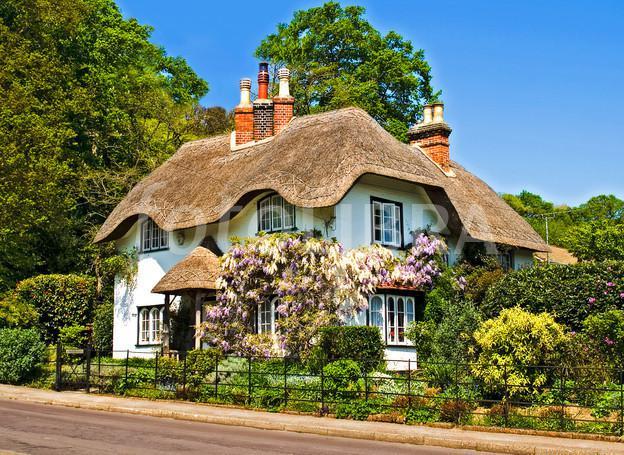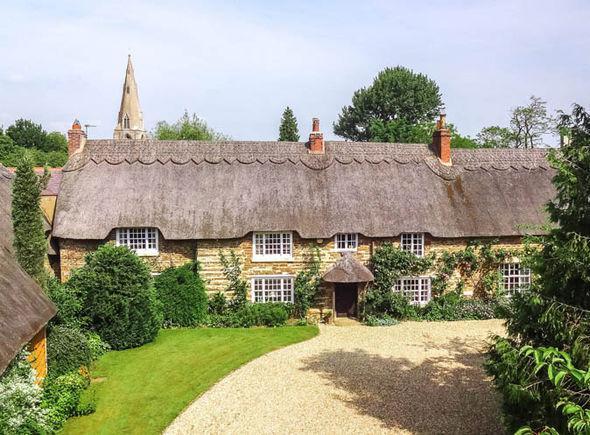The first image is the image on the left, the second image is the image on the right. Analyze the images presented: Is the assertion "One roof is partly supported by posts." valid? Answer yes or no. No. The first image is the image on the left, the second image is the image on the right. Evaluate the accuracy of this statement regarding the images: "The house on the left is behind a fence.". Is it true? Answer yes or no. Yes. 